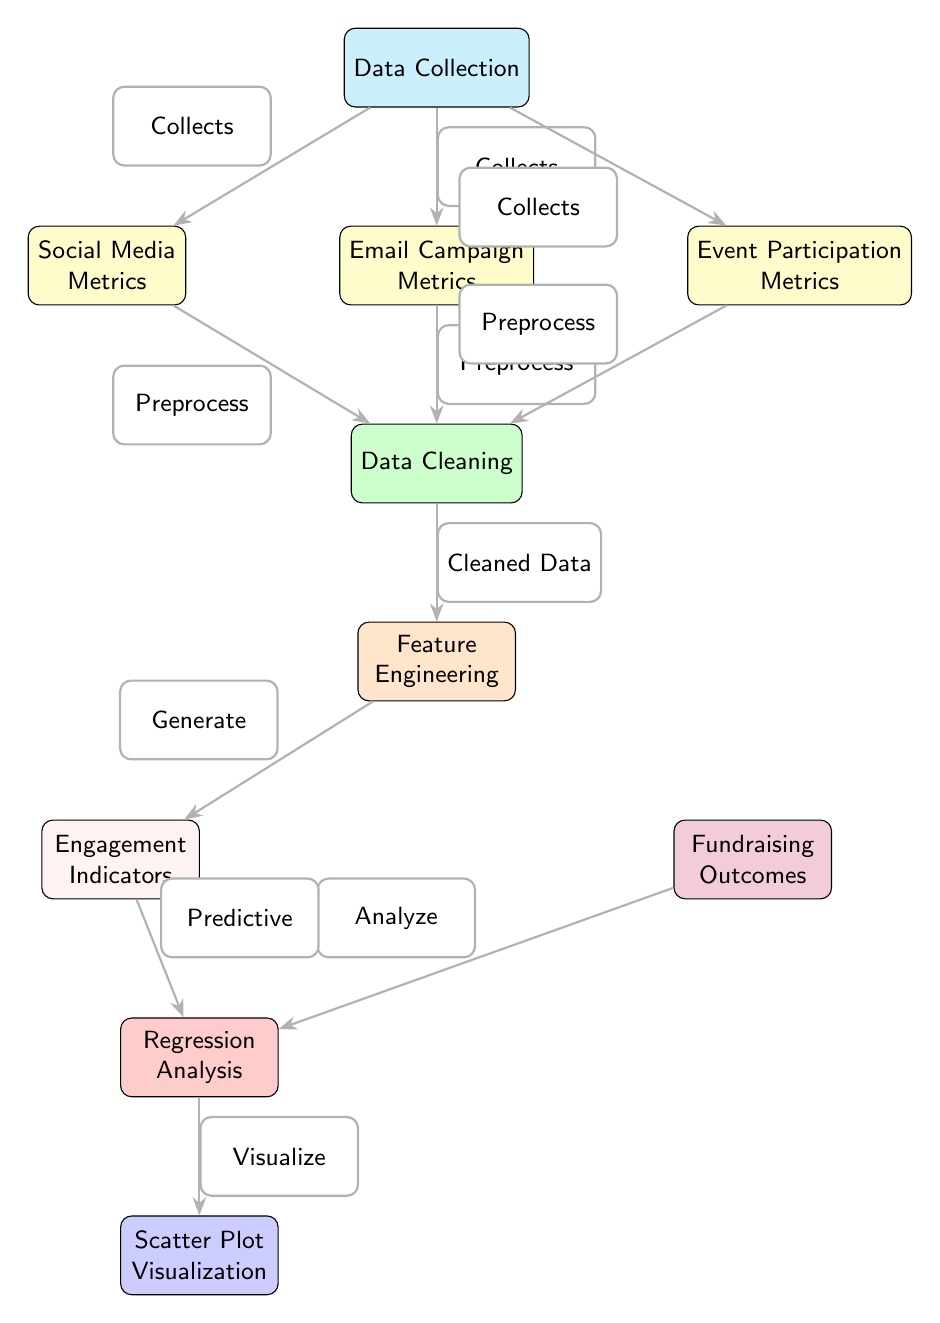What is the last node in the diagram? The last node in the diagram is identified by the downward flow from the "Regression Analysis" node, leading to the "Scatter Plot Visualization" node, which represents the final output.
Answer: Scatter Plot Visualization How many distinct metrics are collected from the first node? The first node, "Data Collection," shows three distinct metrics collected: "Social Media Metrics," "Email Campaign Metrics," and "Event Participation Metrics," indicating three branches.
Answer: Three Which nodes contribute to the "Cleaned Data"? The "Cleaned Data" node receives input from three previous nodes: "Social Media Metrics," "Email Campaign Metrics," and "Event Participation Metrics," each indicating that these metrics undergo preprocessing before cleaning.
Answer: Social Media Metrics, Email Campaign Metrics, Event Participation Metrics What is the purpose of the "Feature Engineering" node in the process? The "Feature Engineering" node takes the "Cleaned Data" and generates "Engagement Indicators," indicating its role in creating relevant features for further analysis, illustrating its necessity in preparing data for predictions.
Answer: Generate Engagement Indicators How does "Engagement Indicators" relate to "Fundraising Outcomes"? The diagram shows that "Engagement Indicators" flow into the "Regression Analysis" node, which takes the "Fundraising Outcomes," suggesting that engagement metrics are utilized to predict fundraising success through regression.
Answer: Predictive Analysis What type of visualization is produced at the end of the process? The final node specifies that a "Scatter Plot Visualization" is created, indicating that the output represents statistical representations of relationships between variables from the regression analysis.
Answer: Scatter Plot Visualization What is the role of the "Data Cleaning" node in this diagram? The "Data Cleaning" node processes incoming data from the "Social Media Metrics," "Email Campaign Metrics," and "Event Participation Metrics," ensuring data is ready for further analysis, which helps in enhancing the quality of predictions.
Answer: Preparing data What processes do the "Engagement Indicators" undergo prior to being analyzed? The "Engagement Indicators" are generated from "Feature Engineering" after the cleaned data process, representing a crucial step in transforming raw data into indicators that can be analyzed for predicting outcomes.
Answer: Generate and Analyze How many nodes are in total in this diagram? There are ten nodes present in the diagram, counting from "Data Collection" through to "Scatter Plot Visualization," providing a comprehensive overview of the steps involved in predicting fundraising success.
Answer: Ten 